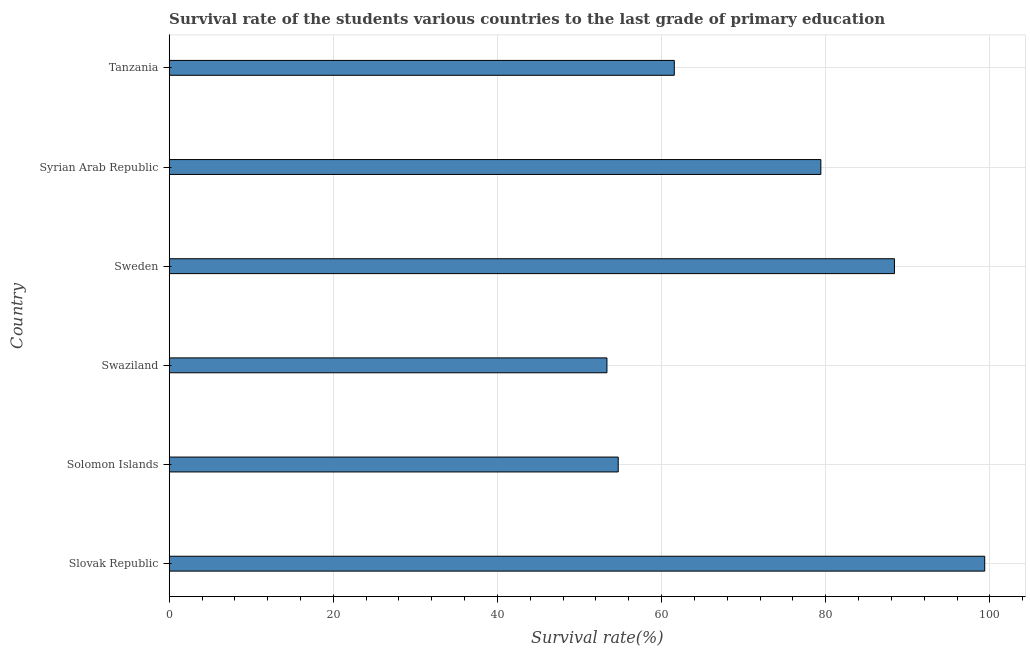Does the graph contain any zero values?
Keep it short and to the point. No. Does the graph contain grids?
Your answer should be very brief. Yes. What is the title of the graph?
Ensure brevity in your answer.  Survival rate of the students various countries to the last grade of primary education. What is the label or title of the X-axis?
Offer a terse response. Survival rate(%). What is the label or title of the Y-axis?
Your answer should be very brief. Country. What is the survival rate in primary education in Tanzania?
Provide a succinct answer. 61.55. Across all countries, what is the maximum survival rate in primary education?
Your answer should be compact. 99.38. Across all countries, what is the minimum survival rate in primary education?
Your answer should be very brief. 53.34. In which country was the survival rate in primary education maximum?
Make the answer very short. Slovak Republic. In which country was the survival rate in primary education minimum?
Your answer should be compact. Swaziland. What is the sum of the survival rate in primary education?
Keep it short and to the point. 436.77. What is the difference between the survival rate in primary education in Solomon Islands and Syrian Arab Republic?
Offer a terse response. -24.69. What is the average survival rate in primary education per country?
Ensure brevity in your answer.  72.8. What is the median survival rate in primary education?
Offer a terse response. 70.48. In how many countries, is the survival rate in primary education greater than 20 %?
Your answer should be very brief. 6. What is the ratio of the survival rate in primary education in Sweden to that in Tanzania?
Ensure brevity in your answer.  1.44. What is the difference between the highest and the second highest survival rate in primary education?
Offer a very short reply. 11. Is the sum of the survival rate in primary education in Swaziland and Syrian Arab Republic greater than the maximum survival rate in primary education across all countries?
Keep it short and to the point. Yes. What is the difference between the highest and the lowest survival rate in primary education?
Ensure brevity in your answer.  46.04. Are the values on the major ticks of X-axis written in scientific E-notation?
Offer a terse response. No. What is the Survival rate(%) in Slovak Republic?
Your answer should be very brief. 99.38. What is the Survival rate(%) of Solomon Islands?
Keep it short and to the point. 54.72. What is the Survival rate(%) of Swaziland?
Give a very brief answer. 53.34. What is the Survival rate(%) in Sweden?
Provide a succinct answer. 88.38. What is the Survival rate(%) of Syrian Arab Republic?
Provide a succinct answer. 79.41. What is the Survival rate(%) of Tanzania?
Ensure brevity in your answer.  61.55. What is the difference between the Survival rate(%) in Slovak Republic and Solomon Islands?
Provide a succinct answer. 44.66. What is the difference between the Survival rate(%) in Slovak Republic and Swaziland?
Your answer should be compact. 46.04. What is the difference between the Survival rate(%) in Slovak Republic and Sweden?
Make the answer very short. 11. What is the difference between the Survival rate(%) in Slovak Republic and Syrian Arab Republic?
Offer a very short reply. 19.97. What is the difference between the Survival rate(%) in Slovak Republic and Tanzania?
Give a very brief answer. 37.83. What is the difference between the Survival rate(%) in Solomon Islands and Swaziland?
Your response must be concise. 1.37. What is the difference between the Survival rate(%) in Solomon Islands and Sweden?
Offer a terse response. -33.66. What is the difference between the Survival rate(%) in Solomon Islands and Syrian Arab Republic?
Your answer should be very brief. -24.69. What is the difference between the Survival rate(%) in Solomon Islands and Tanzania?
Provide a succinct answer. -6.83. What is the difference between the Survival rate(%) in Swaziland and Sweden?
Offer a very short reply. -35.04. What is the difference between the Survival rate(%) in Swaziland and Syrian Arab Republic?
Your answer should be very brief. -26.07. What is the difference between the Survival rate(%) in Swaziland and Tanzania?
Provide a short and direct response. -8.21. What is the difference between the Survival rate(%) in Sweden and Syrian Arab Republic?
Your answer should be very brief. 8.97. What is the difference between the Survival rate(%) in Sweden and Tanzania?
Your answer should be compact. 26.83. What is the difference between the Survival rate(%) in Syrian Arab Republic and Tanzania?
Ensure brevity in your answer.  17.86. What is the ratio of the Survival rate(%) in Slovak Republic to that in Solomon Islands?
Provide a short and direct response. 1.82. What is the ratio of the Survival rate(%) in Slovak Republic to that in Swaziland?
Provide a succinct answer. 1.86. What is the ratio of the Survival rate(%) in Slovak Republic to that in Sweden?
Ensure brevity in your answer.  1.12. What is the ratio of the Survival rate(%) in Slovak Republic to that in Syrian Arab Republic?
Make the answer very short. 1.25. What is the ratio of the Survival rate(%) in Slovak Republic to that in Tanzania?
Offer a very short reply. 1.61. What is the ratio of the Survival rate(%) in Solomon Islands to that in Sweden?
Give a very brief answer. 0.62. What is the ratio of the Survival rate(%) in Solomon Islands to that in Syrian Arab Republic?
Offer a terse response. 0.69. What is the ratio of the Survival rate(%) in Solomon Islands to that in Tanzania?
Your answer should be compact. 0.89. What is the ratio of the Survival rate(%) in Swaziland to that in Sweden?
Provide a short and direct response. 0.6. What is the ratio of the Survival rate(%) in Swaziland to that in Syrian Arab Republic?
Give a very brief answer. 0.67. What is the ratio of the Survival rate(%) in Swaziland to that in Tanzania?
Provide a short and direct response. 0.87. What is the ratio of the Survival rate(%) in Sweden to that in Syrian Arab Republic?
Ensure brevity in your answer.  1.11. What is the ratio of the Survival rate(%) in Sweden to that in Tanzania?
Your answer should be very brief. 1.44. What is the ratio of the Survival rate(%) in Syrian Arab Republic to that in Tanzania?
Your answer should be very brief. 1.29. 